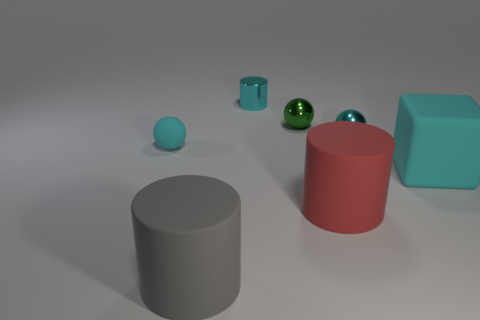There is a small cyan object that is both right of the tiny matte thing and in front of the small green metal sphere; what material is it made of?
Your response must be concise. Metal. What shape is the small metallic object that is the same color as the small cylinder?
Offer a terse response. Sphere. There is a tiny cyan object to the right of the red rubber thing; what is it made of?
Your response must be concise. Metal. Is the green metallic thing the same size as the red cylinder?
Your answer should be compact. No. Is the number of cyan matte objects that are to the left of the big red object greater than the number of tiny rubber blocks?
Provide a succinct answer. Yes. There is a red cylinder that is the same material as the block; what size is it?
Provide a short and direct response. Large. Are there any rubber blocks to the right of the cyan metallic cylinder?
Keep it short and to the point. Yes. Does the large gray object have the same shape as the big red matte object?
Offer a terse response. Yes. What is the size of the cyan matte thing on the right side of the cyan sphere behind the small cyan ball to the left of the red rubber thing?
Your answer should be compact. Large. What is the material of the green sphere?
Offer a terse response. Metal. 